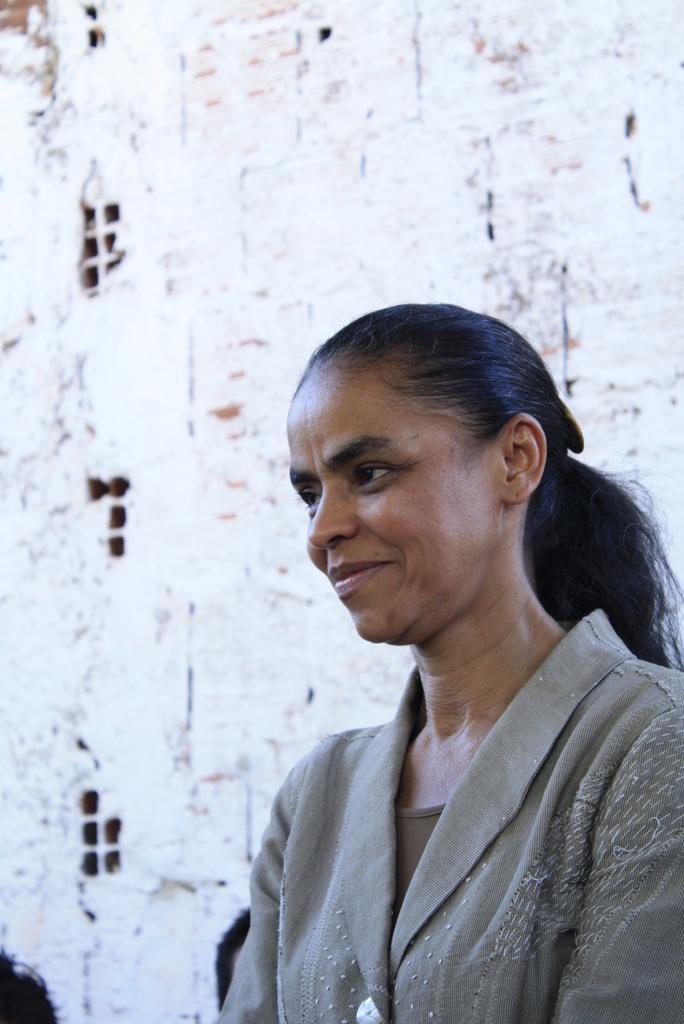In one or two sentences, can you explain what this image depicts? In this image I can see a woman in the front and I can see smile on her face. I can also see she is wearing grey colour dress. In the background I can see white colour wall and on the bottom left side I can see few black colour things. 